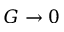<formula> <loc_0><loc_0><loc_500><loc_500>G \rightarrow 0</formula> 